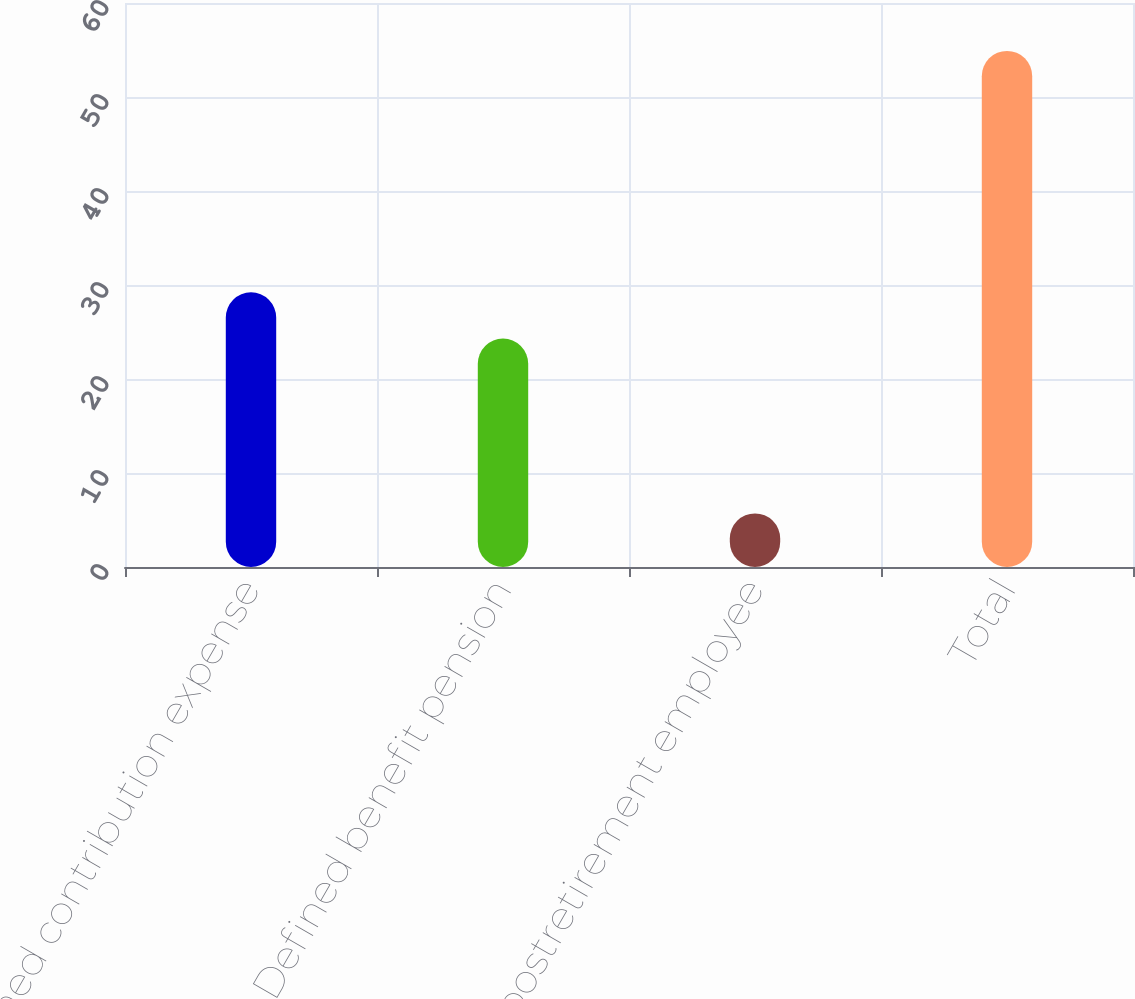<chart> <loc_0><loc_0><loc_500><loc_500><bar_chart><fcel>Defined contribution expense<fcel>Defined benefit pension<fcel>Other postretirement employee<fcel>Total<nl><fcel>29.22<fcel>24.3<fcel>5.7<fcel>54.9<nl></chart> 